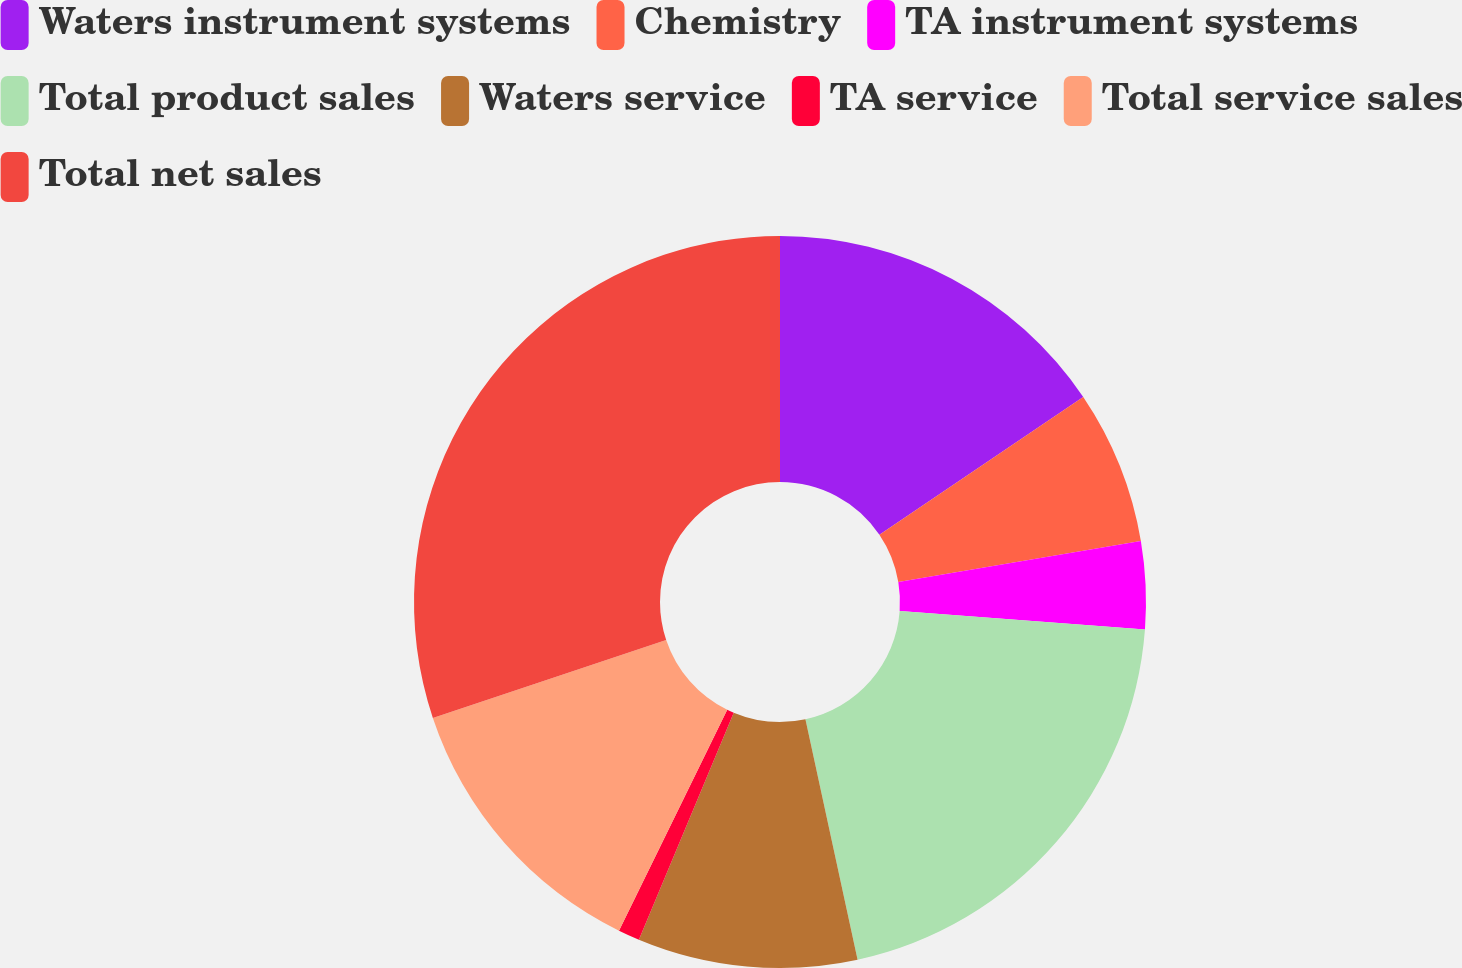<chart> <loc_0><loc_0><loc_500><loc_500><pie_chart><fcel>Waters instrument systems<fcel>Chemistry<fcel>TA instrument systems<fcel>Total product sales<fcel>Waters service<fcel>TA service<fcel>Total service sales<fcel>Total net sales<nl><fcel>15.54%<fcel>6.79%<fcel>3.87%<fcel>20.4%<fcel>9.7%<fcel>0.95%<fcel>12.62%<fcel>30.13%<nl></chart> 